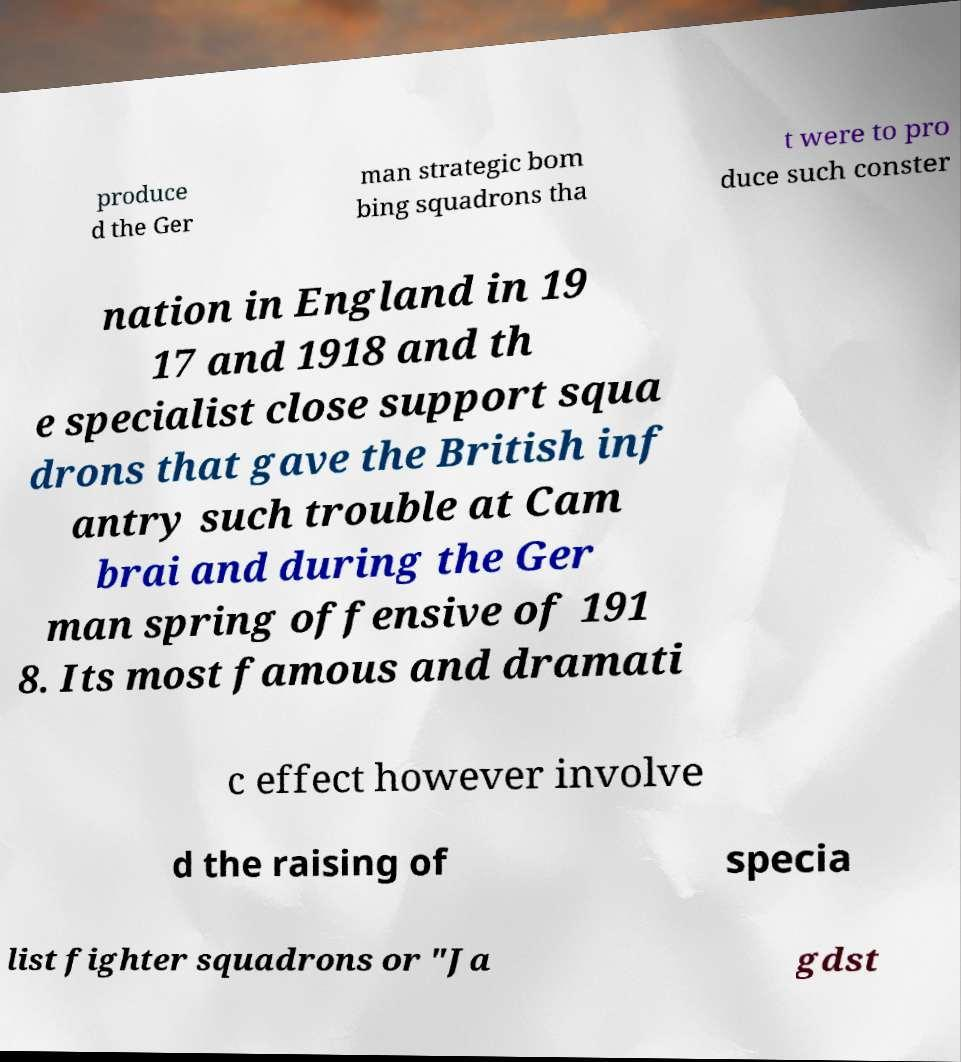Please read and relay the text visible in this image. What does it say? produce d the Ger man strategic bom bing squadrons tha t were to pro duce such conster nation in England in 19 17 and 1918 and th e specialist close support squa drons that gave the British inf antry such trouble at Cam brai and during the Ger man spring offensive of 191 8. Its most famous and dramati c effect however involve d the raising of specia list fighter squadrons or "Ja gdst 